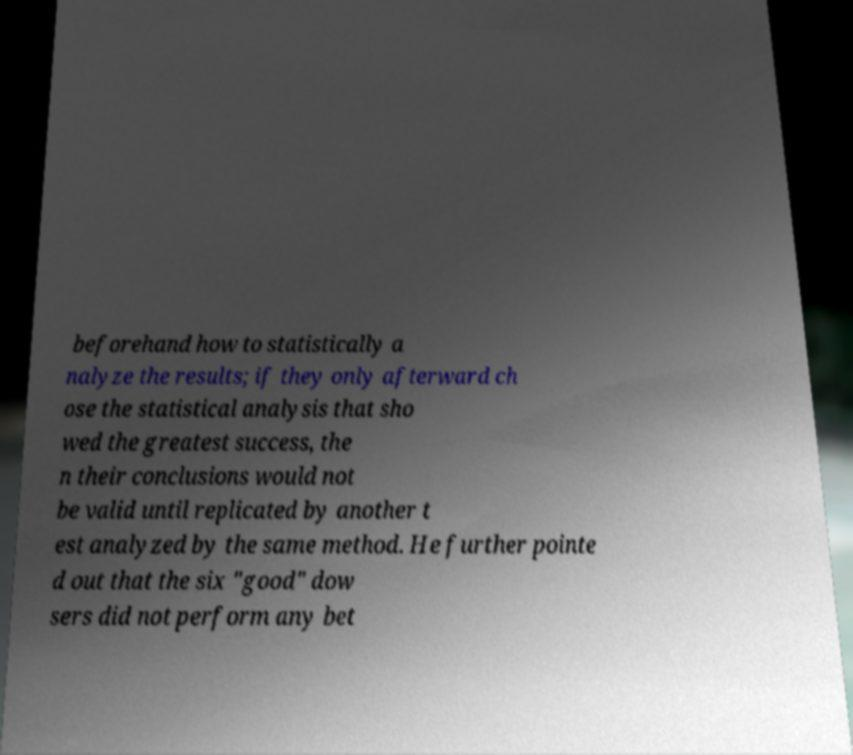Could you extract and type out the text from this image? beforehand how to statistically a nalyze the results; if they only afterward ch ose the statistical analysis that sho wed the greatest success, the n their conclusions would not be valid until replicated by another t est analyzed by the same method. He further pointe d out that the six "good" dow sers did not perform any bet 